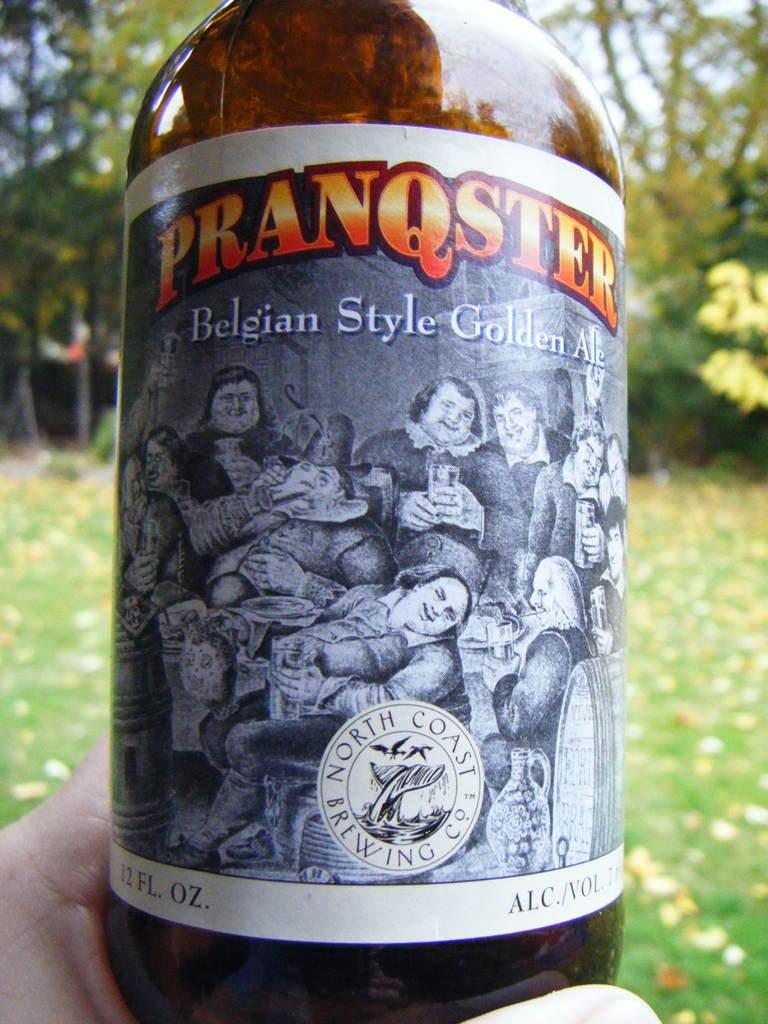What style of beer is this?
Provide a succinct answer. Belgian style golden ale. How many ounces is this?
Provide a succinct answer. 12. 